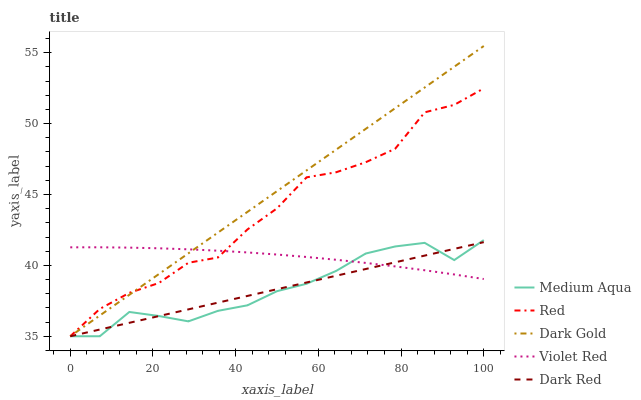Does Dark Red have the minimum area under the curve?
Answer yes or no. Yes. Does Dark Gold have the maximum area under the curve?
Answer yes or no. Yes. Does Violet Red have the minimum area under the curve?
Answer yes or no. No. Does Violet Red have the maximum area under the curve?
Answer yes or no. No. Is Dark Red the smoothest?
Answer yes or no. Yes. Is Red the roughest?
Answer yes or no. Yes. Is Violet Red the smoothest?
Answer yes or no. No. Is Violet Red the roughest?
Answer yes or no. No. Does Violet Red have the lowest value?
Answer yes or no. No. Does Dark Gold have the highest value?
Answer yes or no. Yes. Does Medium Aqua have the highest value?
Answer yes or no. No. Does Medium Aqua intersect Red?
Answer yes or no. Yes. Is Medium Aqua less than Red?
Answer yes or no. No. Is Medium Aqua greater than Red?
Answer yes or no. No. 